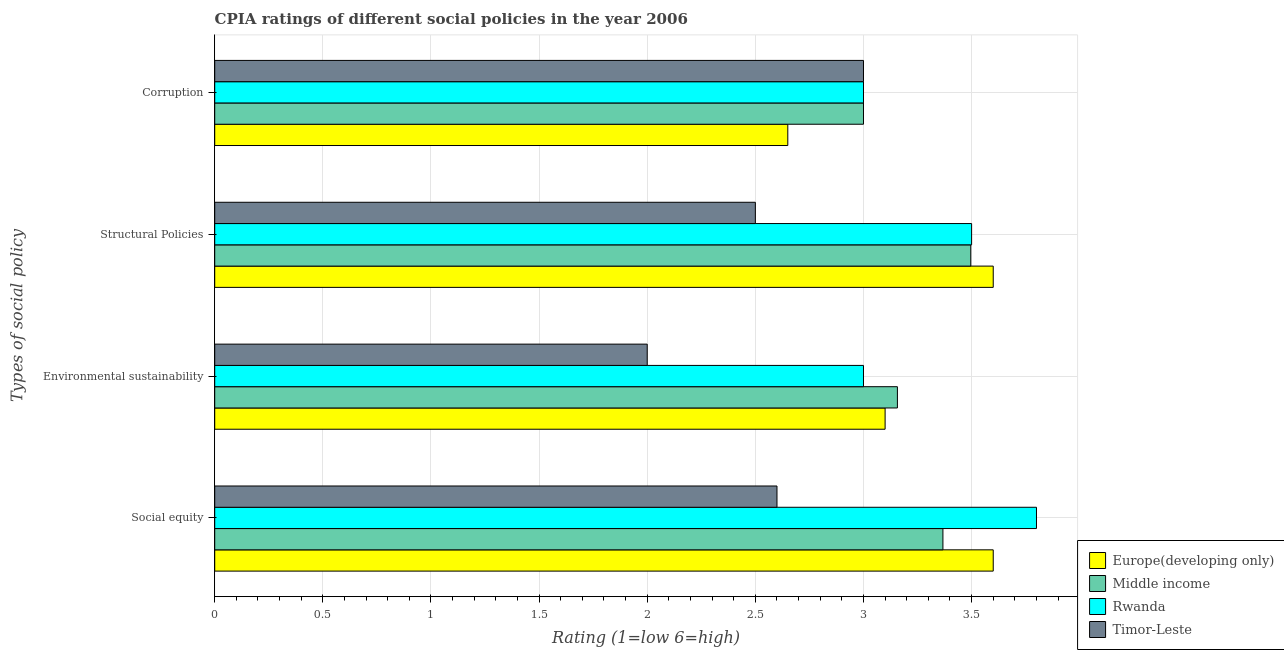How many different coloured bars are there?
Provide a short and direct response. 4. Are the number of bars per tick equal to the number of legend labels?
Ensure brevity in your answer.  Yes. How many bars are there on the 1st tick from the bottom?
Give a very brief answer. 4. What is the label of the 4th group of bars from the top?
Make the answer very short. Social equity. What is the cpia rating of social equity in Middle income?
Provide a succinct answer. 3.37. Across all countries, what is the maximum cpia rating of social equity?
Offer a terse response. 3.8. Across all countries, what is the minimum cpia rating of corruption?
Keep it short and to the point. 2.65. In which country was the cpia rating of structural policies maximum?
Make the answer very short. Europe(developing only). In which country was the cpia rating of environmental sustainability minimum?
Keep it short and to the point. Timor-Leste. What is the total cpia rating of environmental sustainability in the graph?
Keep it short and to the point. 11.26. What is the average cpia rating of corruption per country?
Your response must be concise. 2.91. What is the difference between the cpia rating of social equity and cpia rating of corruption in Rwanda?
Offer a very short reply. 0.8. What is the ratio of the cpia rating of structural policies in Rwanda to that in Europe(developing only)?
Offer a very short reply. 0.97. What is the difference between the highest and the second highest cpia rating of social equity?
Provide a short and direct response. 0.2. What is the difference between the highest and the lowest cpia rating of structural policies?
Your answer should be compact. 1.1. In how many countries, is the cpia rating of social equity greater than the average cpia rating of social equity taken over all countries?
Keep it short and to the point. 3. Is the sum of the cpia rating of environmental sustainability in Rwanda and Middle income greater than the maximum cpia rating of corruption across all countries?
Give a very brief answer. Yes. What does the 1st bar from the top in Structural Policies represents?
Ensure brevity in your answer.  Timor-Leste. What is the difference between two consecutive major ticks on the X-axis?
Give a very brief answer. 0.5. Where does the legend appear in the graph?
Give a very brief answer. Bottom right. How many legend labels are there?
Keep it short and to the point. 4. What is the title of the graph?
Your answer should be very brief. CPIA ratings of different social policies in the year 2006. What is the label or title of the Y-axis?
Provide a short and direct response. Types of social policy. What is the Rating (1=low 6=high) in Europe(developing only) in Social equity?
Make the answer very short. 3.6. What is the Rating (1=low 6=high) of Middle income in Social equity?
Give a very brief answer. 3.37. What is the Rating (1=low 6=high) in Rwanda in Social equity?
Ensure brevity in your answer.  3.8. What is the Rating (1=low 6=high) in Timor-Leste in Social equity?
Your answer should be compact. 2.6. What is the Rating (1=low 6=high) of Europe(developing only) in Environmental sustainability?
Offer a terse response. 3.1. What is the Rating (1=low 6=high) of Middle income in Environmental sustainability?
Your response must be concise. 3.16. What is the Rating (1=low 6=high) in Rwanda in Environmental sustainability?
Your answer should be very brief. 3. What is the Rating (1=low 6=high) in Timor-Leste in Environmental sustainability?
Ensure brevity in your answer.  2. What is the Rating (1=low 6=high) of Europe(developing only) in Structural Policies?
Offer a very short reply. 3.6. What is the Rating (1=low 6=high) in Middle income in Structural Policies?
Your answer should be very brief. 3.5. What is the Rating (1=low 6=high) of Timor-Leste in Structural Policies?
Offer a terse response. 2.5. What is the Rating (1=low 6=high) of Europe(developing only) in Corruption?
Your response must be concise. 2.65. What is the Rating (1=low 6=high) of Middle income in Corruption?
Give a very brief answer. 3. Across all Types of social policy, what is the maximum Rating (1=low 6=high) in Europe(developing only)?
Provide a succinct answer. 3.6. Across all Types of social policy, what is the maximum Rating (1=low 6=high) of Middle income?
Your response must be concise. 3.5. Across all Types of social policy, what is the maximum Rating (1=low 6=high) of Rwanda?
Give a very brief answer. 3.8. Across all Types of social policy, what is the minimum Rating (1=low 6=high) of Europe(developing only)?
Provide a short and direct response. 2.65. Across all Types of social policy, what is the minimum Rating (1=low 6=high) of Middle income?
Ensure brevity in your answer.  3. Across all Types of social policy, what is the minimum Rating (1=low 6=high) of Timor-Leste?
Your answer should be compact. 2. What is the total Rating (1=low 6=high) in Europe(developing only) in the graph?
Offer a terse response. 12.95. What is the total Rating (1=low 6=high) in Middle income in the graph?
Provide a succinct answer. 13.02. What is the total Rating (1=low 6=high) of Rwanda in the graph?
Make the answer very short. 13.3. What is the total Rating (1=low 6=high) in Timor-Leste in the graph?
Make the answer very short. 10.1. What is the difference between the Rating (1=low 6=high) in Europe(developing only) in Social equity and that in Environmental sustainability?
Your response must be concise. 0.5. What is the difference between the Rating (1=low 6=high) in Middle income in Social equity and that in Environmental sustainability?
Keep it short and to the point. 0.21. What is the difference between the Rating (1=low 6=high) of Timor-Leste in Social equity and that in Environmental sustainability?
Keep it short and to the point. 0.6. What is the difference between the Rating (1=low 6=high) in Europe(developing only) in Social equity and that in Structural Policies?
Offer a very short reply. 0. What is the difference between the Rating (1=low 6=high) of Middle income in Social equity and that in Structural Policies?
Provide a short and direct response. -0.13. What is the difference between the Rating (1=low 6=high) of Europe(developing only) in Social equity and that in Corruption?
Keep it short and to the point. 0.95. What is the difference between the Rating (1=low 6=high) in Middle income in Social equity and that in Corruption?
Offer a terse response. 0.37. What is the difference between the Rating (1=low 6=high) in Timor-Leste in Social equity and that in Corruption?
Keep it short and to the point. -0.4. What is the difference between the Rating (1=low 6=high) of Middle income in Environmental sustainability and that in Structural Policies?
Your answer should be compact. -0.34. What is the difference between the Rating (1=low 6=high) of Timor-Leste in Environmental sustainability and that in Structural Policies?
Give a very brief answer. -0.5. What is the difference between the Rating (1=low 6=high) of Europe(developing only) in Environmental sustainability and that in Corruption?
Your answer should be compact. 0.45. What is the difference between the Rating (1=low 6=high) of Middle income in Environmental sustainability and that in Corruption?
Offer a terse response. 0.16. What is the difference between the Rating (1=low 6=high) in Rwanda in Environmental sustainability and that in Corruption?
Your response must be concise. 0. What is the difference between the Rating (1=low 6=high) in Europe(developing only) in Structural Policies and that in Corruption?
Provide a short and direct response. 0.95. What is the difference between the Rating (1=low 6=high) in Middle income in Structural Policies and that in Corruption?
Provide a succinct answer. 0.5. What is the difference between the Rating (1=low 6=high) in Timor-Leste in Structural Policies and that in Corruption?
Ensure brevity in your answer.  -0.5. What is the difference between the Rating (1=low 6=high) of Europe(developing only) in Social equity and the Rating (1=low 6=high) of Middle income in Environmental sustainability?
Make the answer very short. 0.44. What is the difference between the Rating (1=low 6=high) in Middle income in Social equity and the Rating (1=low 6=high) in Rwanda in Environmental sustainability?
Keep it short and to the point. 0.37. What is the difference between the Rating (1=low 6=high) in Middle income in Social equity and the Rating (1=low 6=high) in Timor-Leste in Environmental sustainability?
Provide a short and direct response. 1.37. What is the difference between the Rating (1=low 6=high) in Europe(developing only) in Social equity and the Rating (1=low 6=high) in Middle income in Structural Policies?
Offer a terse response. 0.1. What is the difference between the Rating (1=low 6=high) of Europe(developing only) in Social equity and the Rating (1=low 6=high) of Rwanda in Structural Policies?
Offer a terse response. 0.1. What is the difference between the Rating (1=low 6=high) of Middle income in Social equity and the Rating (1=low 6=high) of Rwanda in Structural Policies?
Ensure brevity in your answer.  -0.13. What is the difference between the Rating (1=low 6=high) of Middle income in Social equity and the Rating (1=low 6=high) of Timor-Leste in Structural Policies?
Keep it short and to the point. 0.87. What is the difference between the Rating (1=low 6=high) of Europe(developing only) in Social equity and the Rating (1=low 6=high) of Middle income in Corruption?
Give a very brief answer. 0.6. What is the difference between the Rating (1=low 6=high) of Europe(developing only) in Social equity and the Rating (1=low 6=high) of Timor-Leste in Corruption?
Make the answer very short. 0.6. What is the difference between the Rating (1=low 6=high) of Middle income in Social equity and the Rating (1=low 6=high) of Rwanda in Corruption?
Ensure brevity in your answer.  0.37. What is the difference between the Rating (1=low 6=high) in Middle income in Social equity and the Rating (1=low 6=high) in Timor-Leste in Corruption?
Your answer should be very brief. 0.37. What is the difference between the Rating (1=low 6=high) of Europe(developing only) in Environmental sustainability and the Rating (1=low 6=high) of Middle income in Structural Policies?
Give a very brief answer. -0.4. What is the difference between the Rating (1=low 6=high) of Europe(developing only) in Environmental sustainability and the Rating (1=low 6=high) of Rwanda in Structural Policies?
Provide a succinct answer. -0.4. What is the difference between the Rating (1=low 6=high) in Europe(developing only) in Environmental sustainability and the Rating (1=low 6=high) in Timor-Leste in Structural Policies?
Provide a short and direct response. 0.6. What is the difference between the Rating (1=low 6=high) of Middle income in Environmental sustainability and the Rating (1=low 6=high) of Rwanda in Structural Policies?
Give a very brief answer. -0.34. What is the difference between the Rating (1=low 6=high) of Middle income in Environmental sustainability and the Rating (1=low 6=high) of Timor-Leste in Structural Policies?
Offer a very short reply. 0.66. What is the difference between the Rating (1=low 6=high) in Rwanda in Environmental sustainability and the Rating (1=low 6=high) in Timor-Leste in Structural Policies?
Your answer should be very brief. 0.5. What is the difference between the Rating (1=low 6=high) of Europe(developing only) in Environmental sustainability and the Rating (1=low 6=high) of Rwanda in Corruption?
Ensure brevity in your answer.  0.1. What is the difference between the Rating (1=low 6=high) of Europe(developing only) in Environmental sustainability and the Rating (1=low 6=high) of Timor-Leste in Corruption?
Make the answer very short. 0.1. What is the difference between the Rating (1=low 6=high) of Middle income in Environmental sustainability and the Rating (1=low 6=high) of Rwanda in Corruption?
Offer a very short reply. 0.16. What is the difference between the Rating (1=low 6=high) in Middle income in Environmental sustainability and the Rating (1=low 6=high) in Timor-Leste in Corruption?
Offer a very short reply. 0.16. What is the difference between the Rating (1=low 6=high) in Europe(developing only) in Structural Policies and the Rating (1=low 6=high) in Middle income in Corruption?
Offer a very short reply. 0.6. What is the difference between the Rating (1=low 6=high) of Europe(developing only) in Structural Policies and the Rating (1=low 6=high) of Rwanda in Corruption?
Offer a very short reply. 0.6. What is the difference between the Rating (1=low 6=high) of Middle income in Structural Policies and the Rating (1=low 6=high) of Rwanda in Corruption?
Give a very brief answer. 0.5. What is the difference between the Rating (1=low 6=high) in Middle income in Structural Policies and the Rating (1=low 6=high) in Timor-Leste in Corruption?
Keep it short and to the point. 0.5. What is the average Rating (1=low 6=high) of Europe(developing only) per Types of social policy?
Give a very brief answer. 3.24. What is the average Rating (1=low 6=high) in Middle income per Types of social policy?
Your response must be concise. 3.26. What is the average Rating (1=low 6=high) in Rwanda per Types of social policy?
Keep it short and to the point. 3.33. What is the average Rating (1=low 6=high) in Timor-Leste per Types of social policy?
Give a very brief answer. 2.52. What is the difference between the Rating (1=low 6=high) in Europe(developing only) and Rating (1=low 6=high) in Middle income in Social equity?
Provide a short and direct response. 0.23. What is the difference between the Rating (1=low 6=high) of Middle income and Rating (1=low 6=high) of Rwanda in Social equity?
Provide a short and direct response. -0.43. What is the difference between the Rating (1=low 6=high) of Middle income and Rating (1=low 6=high) of Timor-Leste in Social equity?
Give a very brief answer. 0.77. What is the difference between the Rating (1=low 6=high) in Rwanda and Rating (1=low 6=high) in Timor-Leste in Social equity?
Provide a succinct answer. 1.2. What is the difference between the Rating (1=low 6=high) in Europe(developing only) and Rating (1=low 6=high) in Middle income in Environmental sustainability?
Offer a terse response. -0.06. What is the difference between the Rating (1=low 6=high) of Middle income and Rating (1=low 6=high) of Rwanda in Environmental sustainability?
Your response must be concise. 0.16. What is the difference between the Rating (1=low 6=high) of Middle income and Rating (1=low 6=high) of Timor-Leste in Environmental sustainability?
Provide a short and direct response. 1.16. What is the difference between the Rating (1=low 6=high) of Europe(developing only) and Rating (1=low 6=high) of Middle income in Structural Policies?
Your response must be concise. 0.1. What is the difference between the Rating (1=low 6=high) of Europe(developing only) and Rating (1=low 6=high) of Timor-Leste in Structural Policies?
Make the answer very short. 1.1. What is the difference between the Rating (1=low 6=high) of Middle income and Rating (1=low 6=high) of Rwanda in Structural Policies?
Offer a terse response. -0. What is the difference between the Rating (1=low 6=high) of Rwanda and Rating (1=low 6=high) of Timor-Leste in Structural Policies?
Provide a short and direct response. 1. What is the difference between the Rating (1=low 6=high) of Europe(developing only) and Rating (1=low 6=high) of Middle income in Corruption?
Your answer should be very brief. -0.35. What is the difference between the Rating (1=low 6=high) in Europe(developing only) and Rating (1=low 6=high) in Rwanda in Corruption?
Provide a short and direct response. -0.35. What is the difference between the Rating (1=low 6=high) of Europe(developing only) and Rating (1=low 6=high) of Timor-Leste in Corruption?
Keep it short and to the point. -0.35. What is the difference between the Rating (1=low 6=high) of Middle income and Rating (1=low 6=high) of Rwanda in Corruption?
Your answer should be compact. 0. What is the difference between the Rating (1=low 6=high) in Middle income and Rating (1=low 6=high) in Timor-Leste in Corruption?
Your answer should be very brief. 0. What is the ratio of the Rating (1=low 6=high) in Europe(developing only) in Social equity to that in Environmental sustainability?
Offer a terse response. 1.16. What is the ratio of the Rating (1=low 6=high) in Middle income in Social equity to that in Environmental sustainability?
Make the answer very short. 1.07. What is the ratio of the Rating (1=low 6=high) in Rwanda in Social equity to that in Environmental sustainability?
Keep it short and to the point. 1.27. What is the ratio of the Rating (1=low 6=high) of Timor-Leste in Social equity to that in Environmental sustainability?
Keep it short and to the point. 1.3. What is the ratio of the Rating (1=low 6=high) of Europe(developing only) in Social equity to that in Structural Policies?
Offer a terse response. 1. What is the ratio of the Rating (1=low 6=high) of Middle income in Social equity to that in Structural Policies?
Make the answer very short. 0.96. What is the ratio of the Rating (1=low 6=high) in Rwanda in Social equity to that in Structural Policies?
Offer a terse response. 1.09. What is the ratio of the Rating (1=low 6=high) in Europe(developing only) in Social equity to that in Corruption?
Offer a very short reply. 1.36. What is the ratio of the Rating (1=low 6=high) of Middle income in Social equity to that in Corruption?
Give a very brief answer. 1.12. What is the ratio of the Rating (1=low 6=high) in Rwanda in Social equity to that in Corruption?
Your answer should be very brief. 1.27. What is the ratio of the Rating (1=low 6=high) of Timor-Leste in Social equity to that in Corruption?
Provide a short and direct response. 0.87. What is the ratio of the Rating (1=low 6=high) in Europe(developing only) in Environmental sustainability to that in Structural Policies?
Provide a short and direct response. 0.86. What is the ratio of the Rating (1=low 6=high) of Middle income in Environmental sustainability to that in Structural Policies?
Your response must be concise. 0.9. What is the ratio of the Rating (1=low 6=high) of Europe(developing only) in Environmental sustainability to that in Corruption?
Offer a very short reply. 1.17. What is the ratio of the Rating (1=low 6=high) of Middle income in Environmental sustainability to that in Corruption?
Provide a succinct answer. 1.05. What is the ratio of the Rating (1=low 6=high) of Rwanda in Environmental sustainability to that in Corruption?
Your response must be concise. 1. What is the ratio of the Rating (1=low 6=high) of Timor-Leste in Environmental sustainability to that in Corruption?
Ensure brevity in your answer.  0.67. What is the ratio of the Rating (1=low 6=high) of Europe(developing only) in Structural Policies to that in Corruption?
Keep it short and to the point. 1.36. What is the ratio of the Rating (1=low 6=high) of Middle income in Structural Policies to that in Corruption?
Make the answer very short. 1.17. What is the difference between the highest and the second highest Rating (1=low 6=high) of Europe(developing only)?
Ensure brevity in your answer.  0. What is the difference between the highest and the second highest Rating (1=low 6=high) of Middle income?
Make the answer very short. 0.13. What is the difference between the highest and the second highest Rating (1=low 6=high) of Rwanda?
Offer a very short reply. 0.3. What is the difference between the highest and the lowest Rating (1=low 6=high) of Europe(developing only)?
Offer a terse response. 0.95. What is the difference between the highest and the lowest Rating (1=low 6=high) of Middle income?
Give a very brief answer. 0.5. What is the difference between the highest and the lowest Rating (1=low 6=high) in Rwanda?
Ensure brevity in your answer.  0.8. 